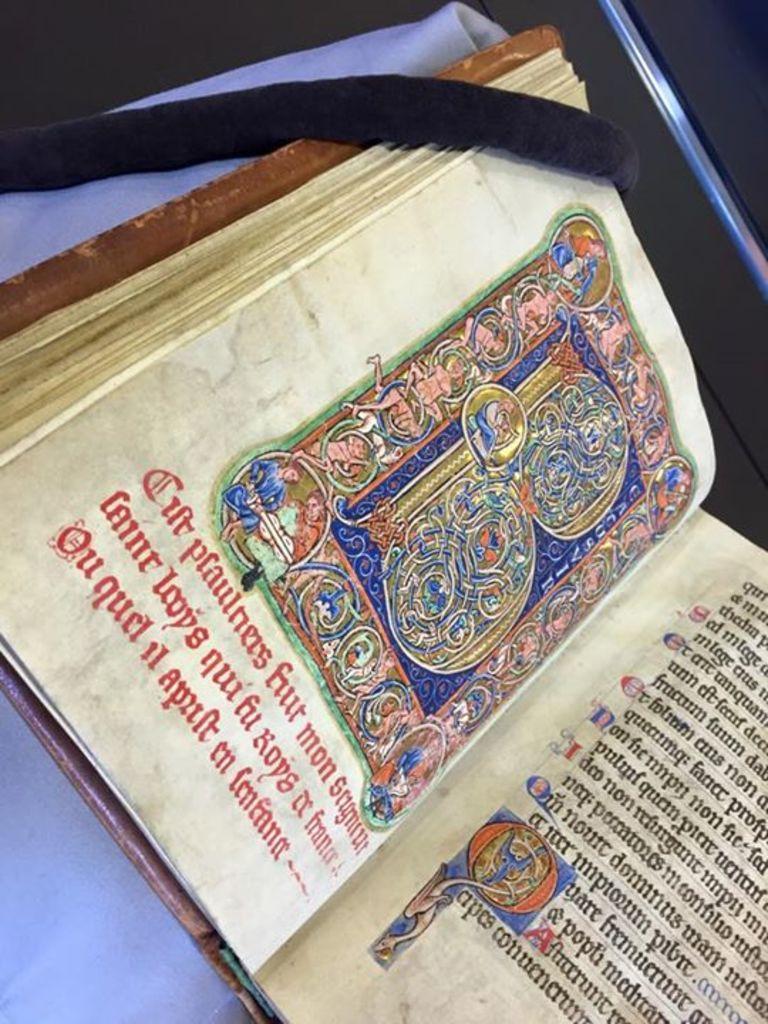What letter is the giant text art?
Provide a short and direct response. B. 